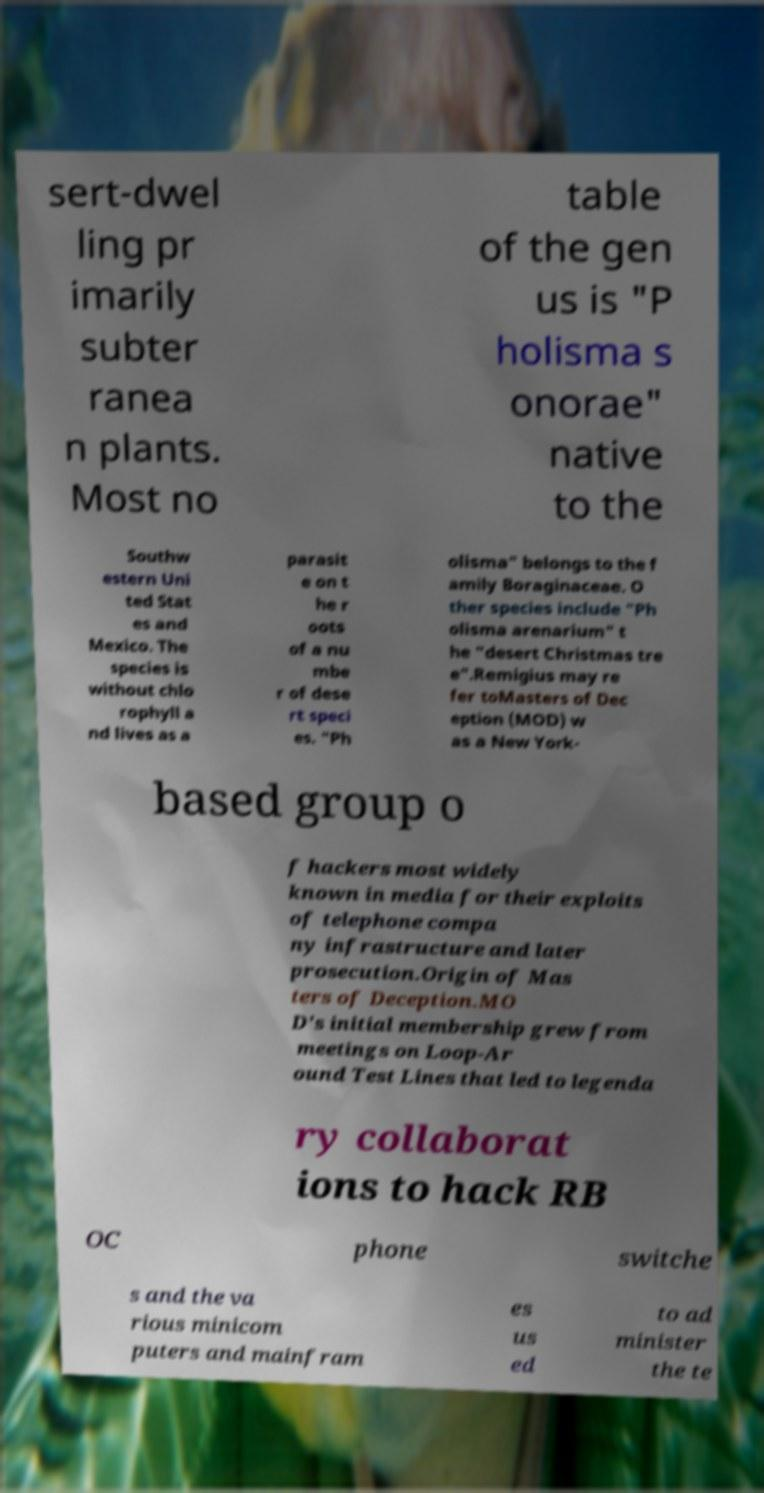Please identify and transcribe the text found in this image. sert-dwel ling pr imarily subter ranea n plants. Most no table of the gen us is "P holisma s onorae" native to the Southw estern Uni ted Stat es and Mexico. The species is without chlo rophyll a nd lives as a parasit e on t he r oots of a nu mbe r of dese rt speci es. "Ph olisma" belongs to the f amily Boraginaceae. O ther species include "Ph olisma arenarium" t he "desert Christmas tre e".Remigius may re fer toMasters of Dec eption (MOD) w as a New York- based group o f hackers most widely known in media for their exploits of telephone compa ny infrastructure and later prosecution.Origin of Mas ters of Deception.MO D's initial membership grew from meetings on Loop-Ar ound Test Lines that led to legenda ry collaborat ions to hack RB OC phone switche s and the va rious minicom puters and mainfram es us ed to ad minister the te 